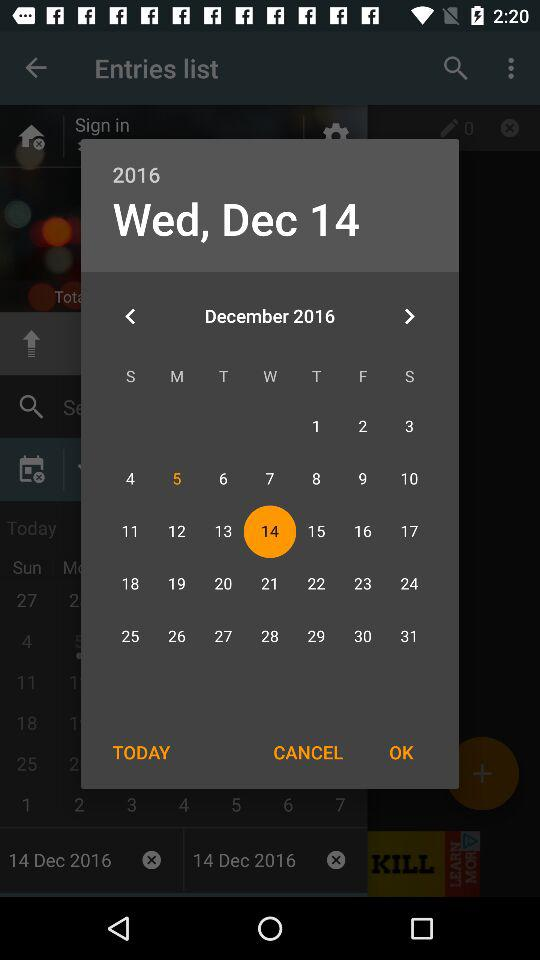Which date is selected? The selected date is Wednesday, December 14, 2016. 